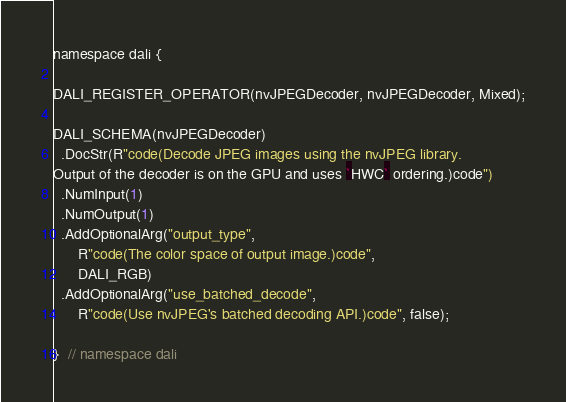Convert code to text. <code><loc_0><loc_0><loc_500><loc_500><_Cuda_>
namespace dali {

DALI_REGISTER_OPERATOR(nvJPEGDecoder, nvJPEGDecoder, Mixed);

DALI_SCHEMA(nvJPEGDecoder)
  .DocStr(R"code(Decode JPEG images using the nvJPEG library.
Output of the decoder is on the GPU and uses `HWC` ordering.)code")
  .NumInput(1)
  .NumOutput(1)
  .AddOptionalArg("output_type",
      R"code(The color space of output image.)code",
      DALI_RGB)
  .AddOptionalArg("use_batched_decode",
      R"code(Use nvJPEG's batched decoding API.)code", false);

}  // namespace dali

</code> 